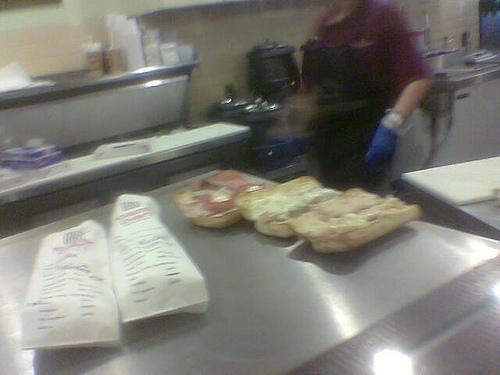How many people are there?
Give a very brief answer. 1. How many white cups?
Give a very brief answer. 0. How many sandwiches are in the picture?
Give a very brief answer. 3. How many beds in this image require a ladder to get into?
Give a very brief answer. 0. 